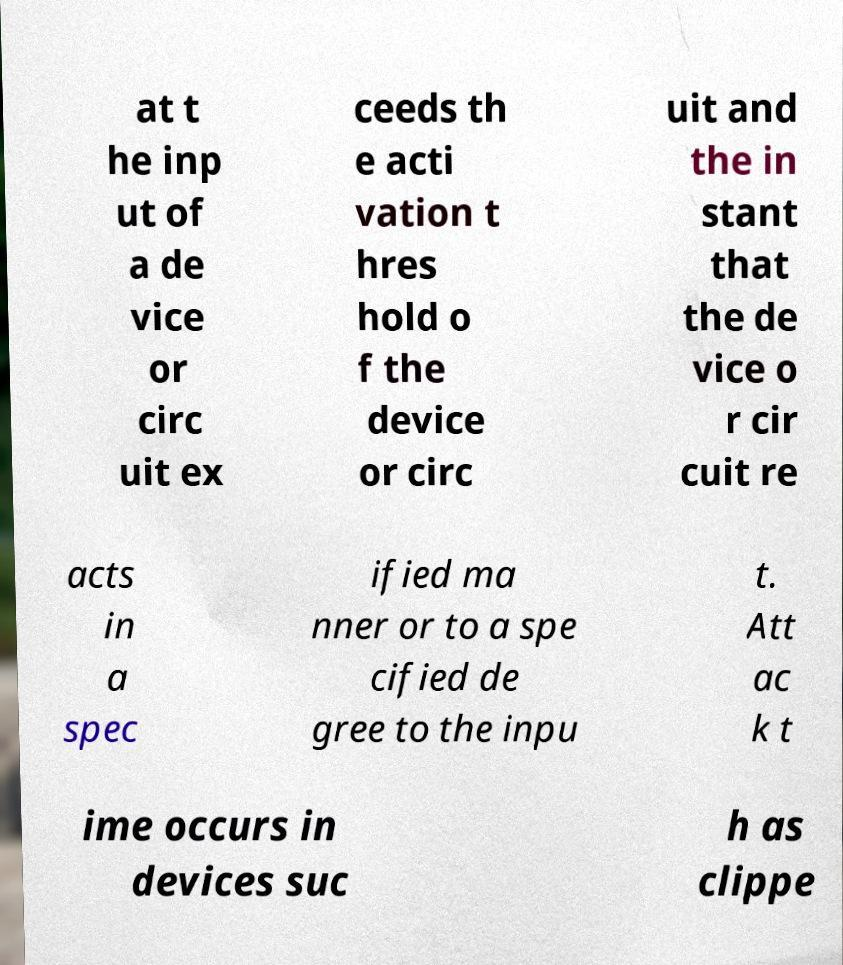Please read and relay the text visible in this image. What does it say? at t he inp ut of a de vice or circ uit ex ceeds th e acti vation t hres hold o f the device or circ uit and the in stant that the de vice o r cir cuit re acts in a spec ified ma nner or to a spe cified de gree to the inpu t. Att ac k t ime occurs in devices suc h as clippe 